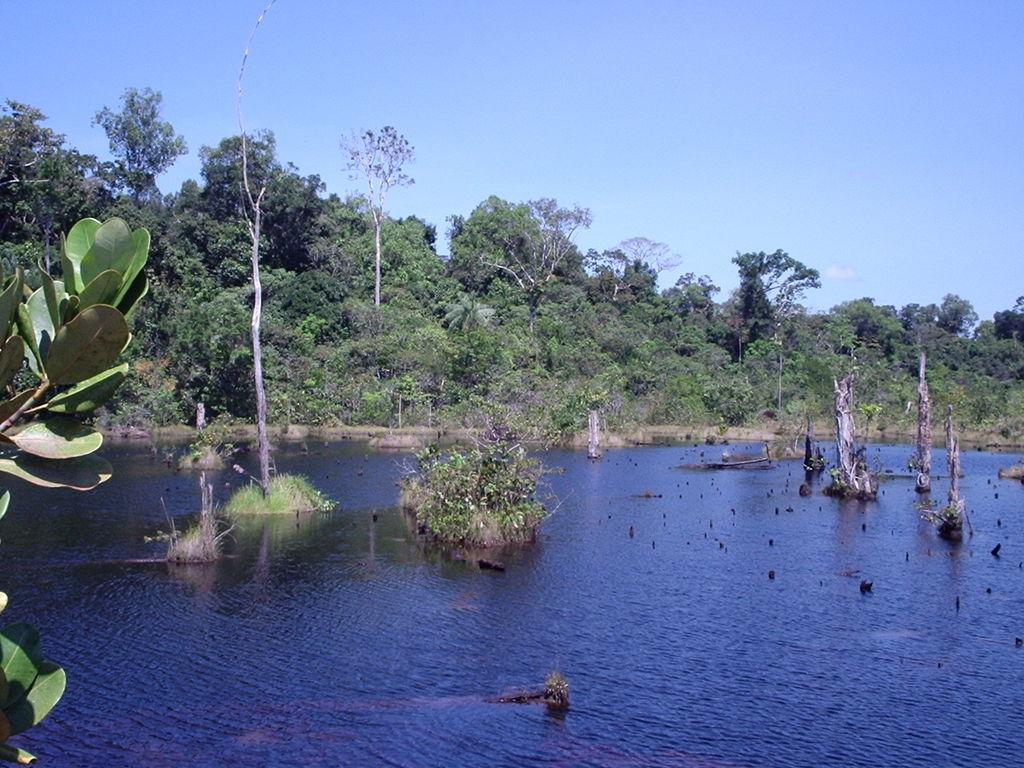What is the primary element in the image? There is water in the image. What can be found within the water? There are plants and tree trunks in the water. What type of vegetation is visible in the background of the image? There are trees in the background of the image. What is visible at the top of the image? The sky is visible at the top of the image. What type of steel structure can be seen in the image? There is no steel structure present in the image. How does the expansion of the water affect the plants in the image? The image does not depict any expansion of the water, so its effect on the plants cannot be determined. 